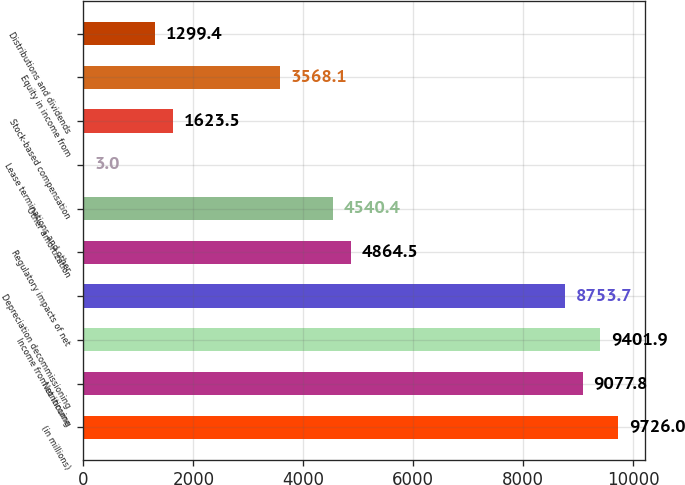Convert chart. <chart><loc_0><loc_0><loc_500><loc_500><bar_chart><fcel>(in millions)<fcel>Net income<fcel>Income from continuing<fcel>Depreciation decommissioning<fcel>Regulatory impacts of net<fcel>Other amortization<fcel>Lease terminations and other<fcel>Stock-based compensation<fcel>Equity in income from<fcel>Distributions and dividends<nl><fcel>9726<fcel>9077.8<fcel>9401.9<fcel>8753.7<fcel>4864.5<fcel>4540.4<fcel>3<fcel>1623.5<fcel>3568.1<fcel>1299.4<nl></chart> 